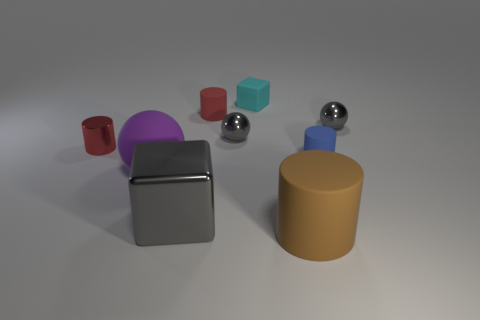The other cylinder that is the same color as the metal cylinder is what size?
Offer a terse response. Small. There is a cyan block that is the same material as the big ball; what size is it?
Offer a terse response. Small. How many small cyan objects have the same shape as the big purple thing?
Your answer should be very brief. 0. There is a block in front of the red rubber cylinder; is it the same color as the metal cylinder?
Provide a short and direct response. No. There is a rubber object that is to the left of the block that is in front of the metal cylinder; how many tiny blue rubber objects are behind it?
Offer a very short reply. 1. How many things are both in front of the small cyan block and on the right side of the large block?
Ensure brevity in your answer.  5. What shape is the tiny matte thing that is the same color as the small metallic cylinder?
Your answer should be very brief. Cylinder. Are there any other things that are made of the same material as the large cube?
Ensure brevity in your answer.  Yes. Does the large brown cylinder have the same material as the cyan block?
Give a very brief answer. Yes. What shape is the brown rubber object that is left of the gray metal ball that is right of the tiny rubber thing in front of the small red matte object?
Give a very brief answer. Cylinder. 